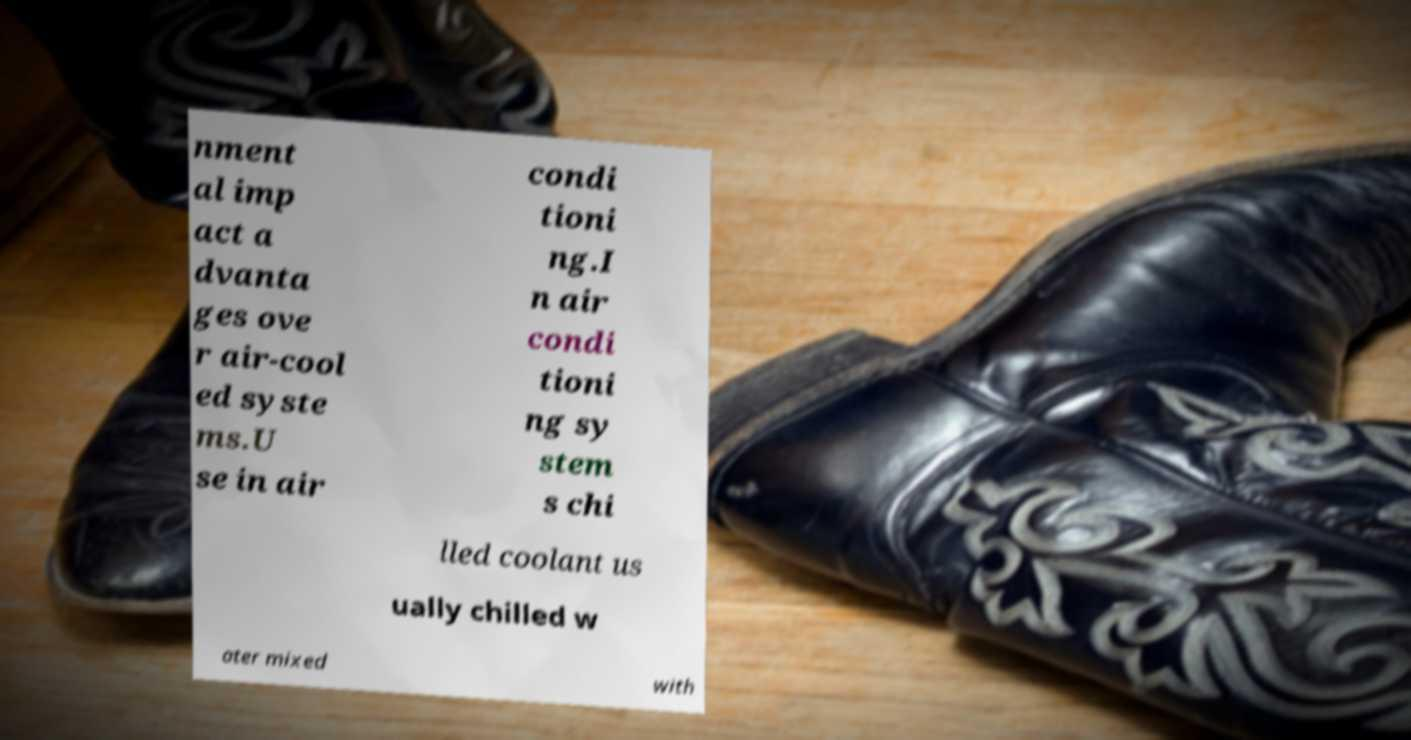Can you accurately transcribe the text from the provided image for me? nment al imp act a dvanta ges ove r air-cool ed syste ms.U se in air condi tioni ng.I n air condi tioni ng sy stem s chi lled coolant us ually chilled w ater mixed with 